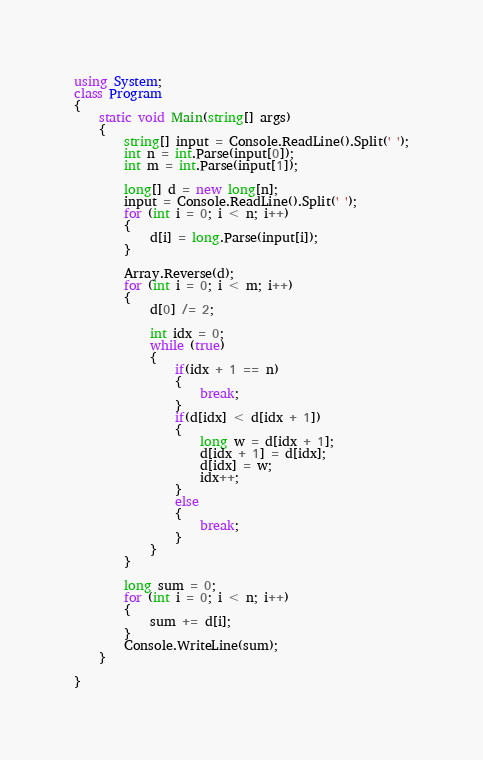Convert code to text. <code><loc_0><loc_0><loc_500><loc_500><_C#_>using System;
class Program
{
    static void Main(string[] args)
    {
        string[] input = Console.ReadLine().Split(' ');
        int n = int.Parse(input[0]);
        int m = int.Parse(input[1]);

        long[] d = new long[n];
        input = Console.ReadLine().Split(' ');
        for (int i = 0; i < n; i++)
        {
            d[i] = long.Parse(input[i]);
        }

        Array.Reverse(d);
        for (int i = 0; i < m; i++)
        {
            d[0] /= 2;

            int idx = 0;
            while (true)
            {
                if(idx + 1 == n)
                {
                    break;
                }
                if(d[idx] < d[idx + 1])
                {
                    long w = d[idx + 1];
                    d[idx + 1] = d[idx];
                    d[idx] = w;
                    idx++;
                }
                else
                {
                    break;
                }
            }
        }

        long sum = 0;
        for (int i = 0; i < n; i++)
        {
            sum += d[i];
        }
        Console.WriteLine(sum);
    }

}</code> 